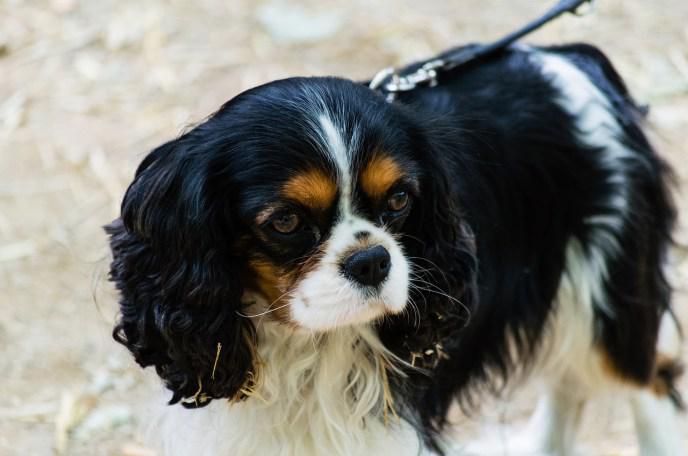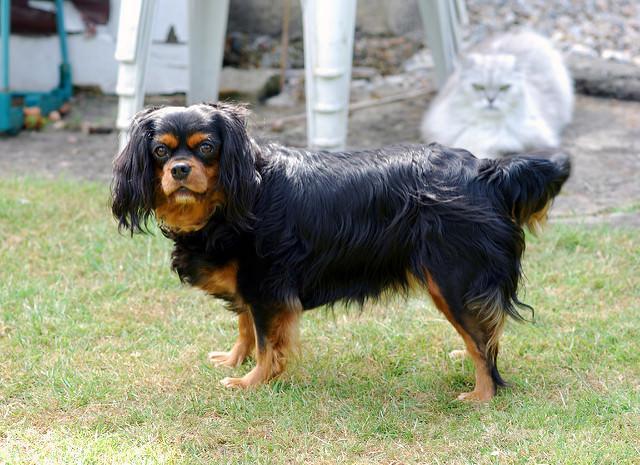The first image is the image on the left, the second image is the image on the right. Examine the images to the left and right. Is the description "There are three dogs in total." accurate? Answer yes or no. No. The first image is the image on the left, the second image is the image on the right. Evaluate the accuracy of this statement regarding the images: "There are three dogs.". Is it true? Answer yes or no. No. 